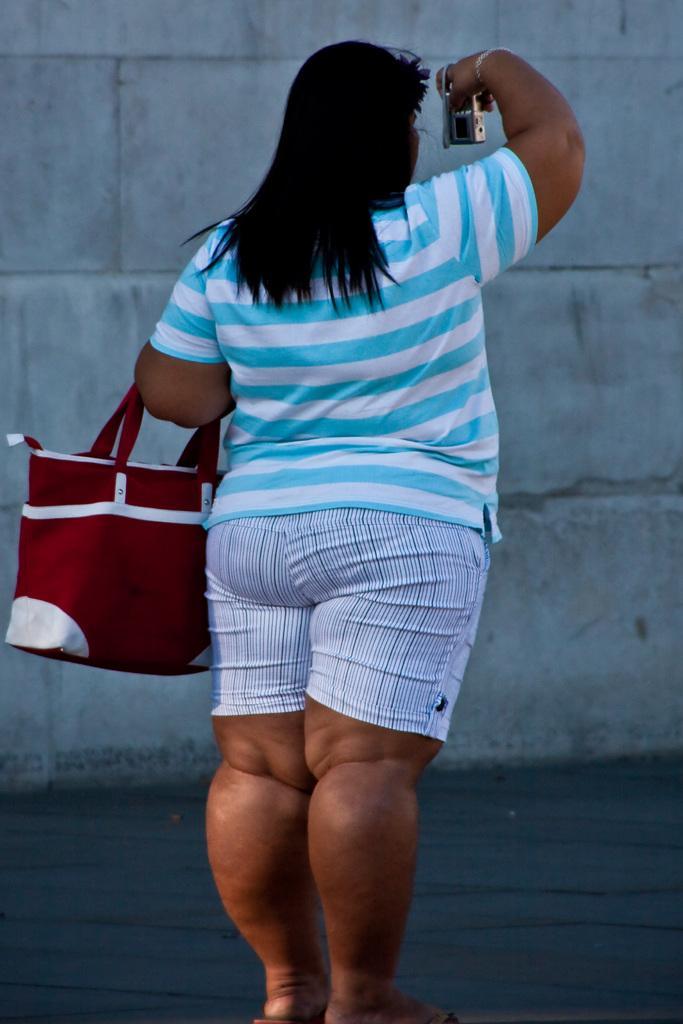In one or two sentences, can you explain what this image depicts? In this picture there is a woman who is wearing t-shirt, short and sleeper. She is holding a camera and red color purse. On the background we can see a wall. 